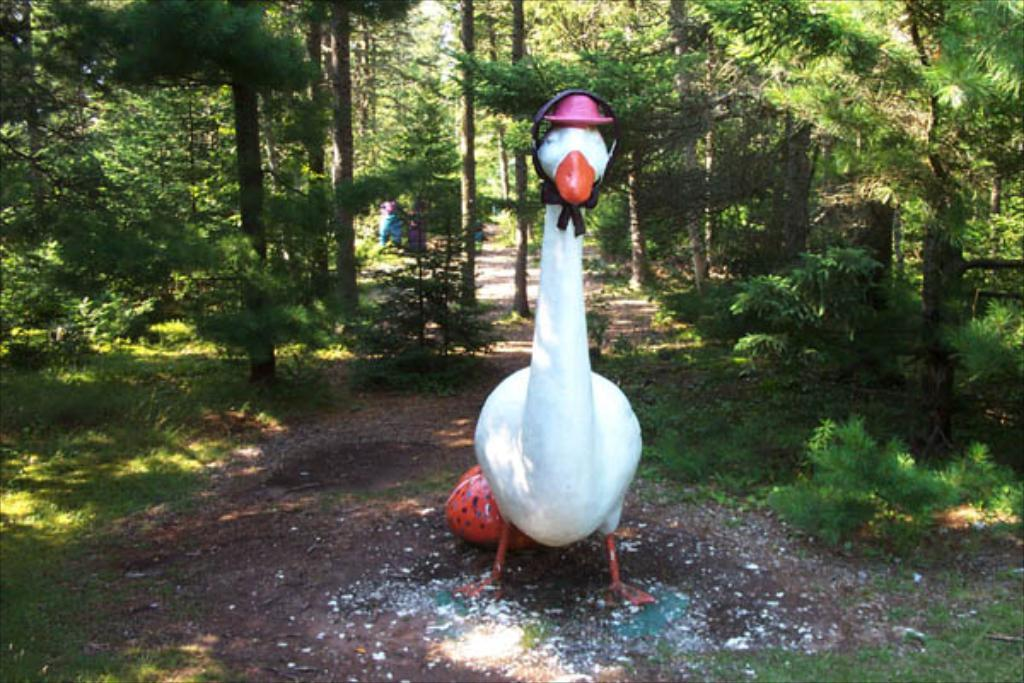What is the main subject of the image? There is a white statue of a duck in the image. What is the color of the grass in the image? There is green grass on the ground in the image. What type of vegetation can be seen in the image? There are plants and trees visible in the image. What color is the sock on the duck's foot in the image? There is no sock present on the duck's foot in the image, as it is a statue and not a living duck. 